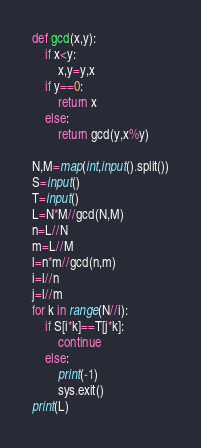<code> <loc_0><loc_0><loc_500><loc_500><_Python_>def gcd(x,y):
    if x<y:
        x,y=y,x
    if y==0:
        return x
    else:
        return gcd(y,x%y)

N,M=map(int,input().split())
S=input()
T=input()
L=N*M//gcd(N,M)
n=L//N
m=L//M
l=n*m//gcd(n,m)
i=l//n
j=l//m
for k in range(N//i):
    if S[i*k]==T[j*k]:
        continue
    else:
        print(-1)
        sys.exit()
print(L)</code> 